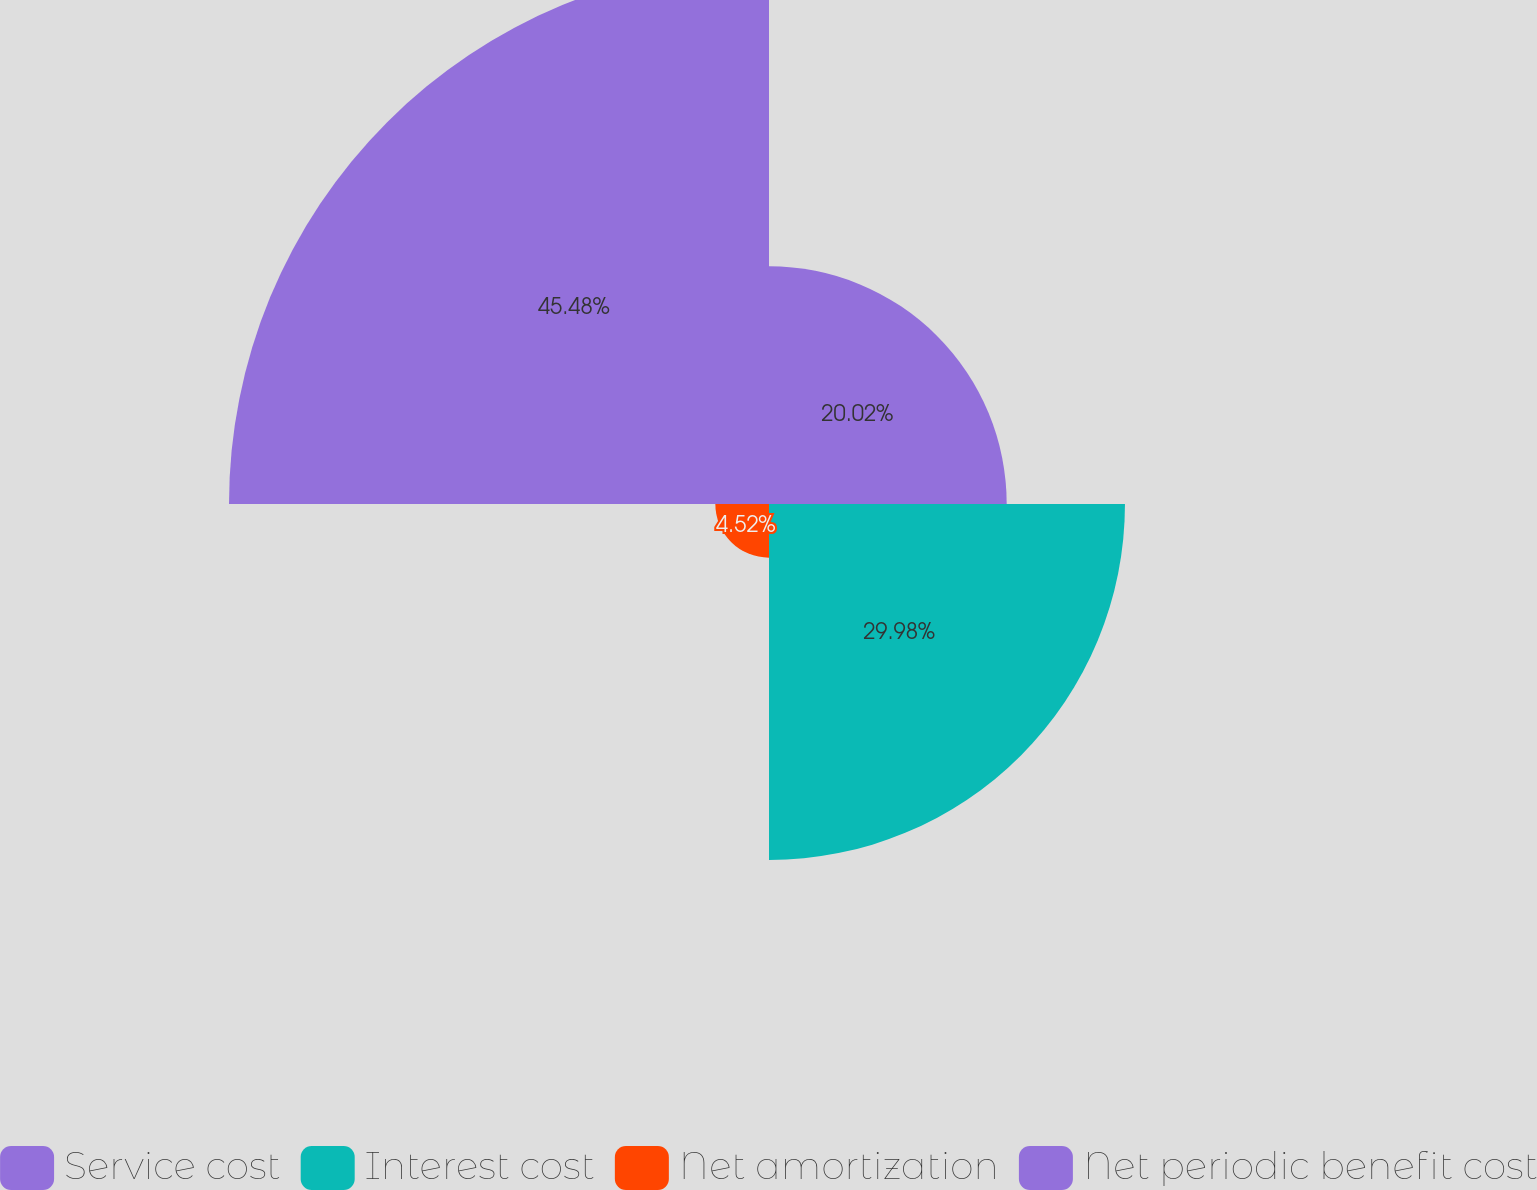Convert chart to OTSL. <chart><loc_0><loc_0><loc_500><loc_500><pie_chart><fcel>Service cost<fcel>Interest cost<fcel>Net amortization<fcel>Net periodic benefit cost<nl><fcel>20.02%<fcel>29.98%<fcel>4.52%<fcel>45.48%<nl></chart> 